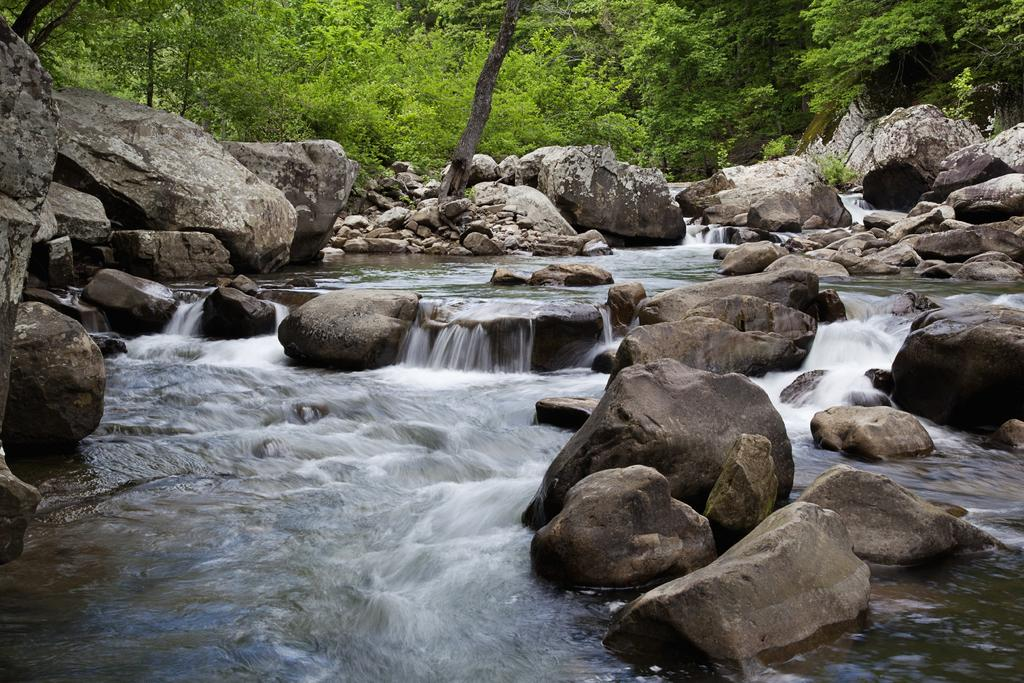What is located at the bottom of the image? There is a river at the bottom of the image. What can be found near the river? There are rocks near the river. What type of vegetation is visible in the background of the image? There is a group of trees in the background of the image. Where is the hammer being used in the image? There is no hammer present in the image. What type of food is being served in the lunchroom in the image? There is no lunchroom present in the image. 